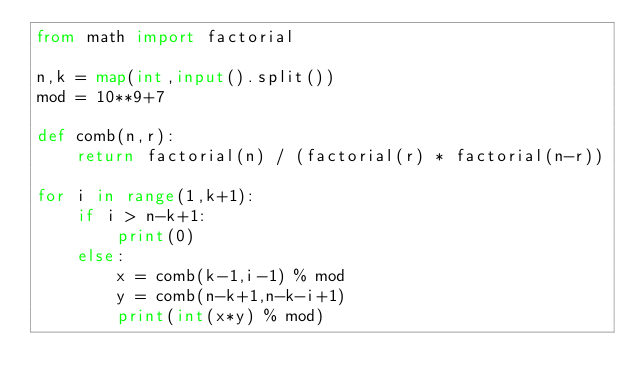Convert code to text. <code><loc_0><loc_0><loc_500><loc_500><_Python_>from math import factorial

n,k = map(int,input().split())
mod = 10**9+7

def comb(n,r):
    return factorial(n) / (factorial(r) * factorial(n-r))

for i in range(1,k+1):
    if i > n-k+1:
        print(0)
    else:
        x = comb(k-1,i-1) % mod
        y = comb(n-k+1,n-k-i+1)
        print(int(x*y) % mod)
</code> 